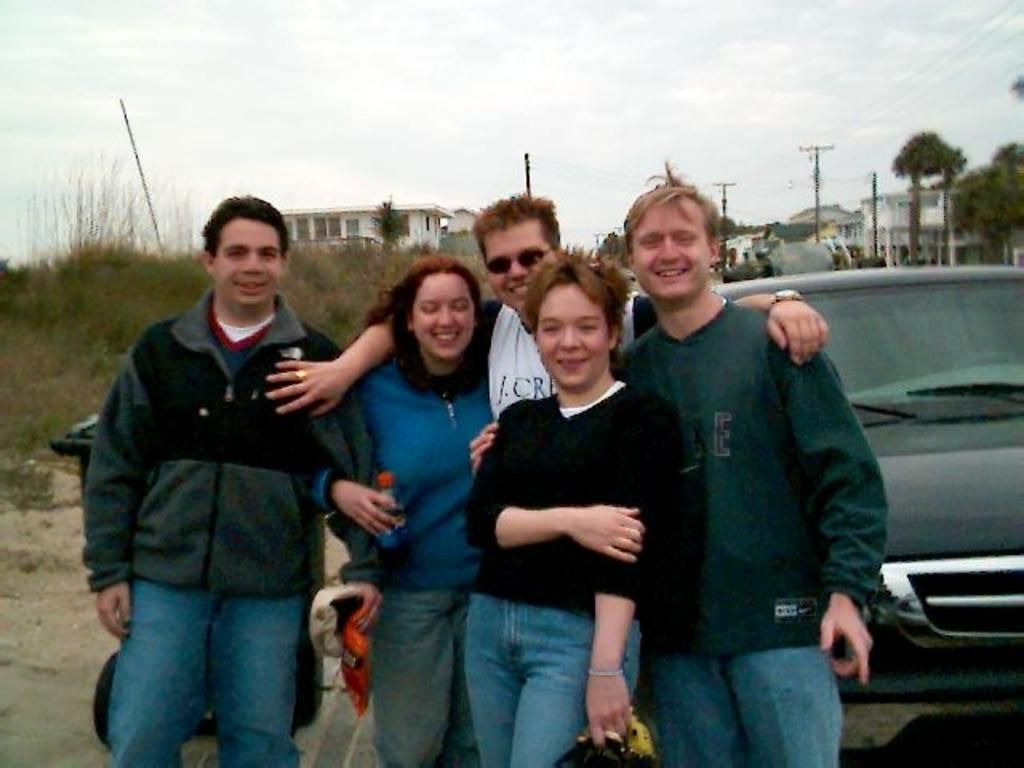What color is the car in the image? The car in the image is black. Who or what else is present in the image besides the car? There are people, buildings, trees, current poles, and plants in the image. What can be seen in the background of the image? Buildings, trees, current poles, and plants can be seen in the background of the image. What is visible at the top of the image? The sky is visible at the top of the image. How does the car's brother help it jump over the current poles in the image? There is no car's brother present in the image, and cars do not jump over current poles. 